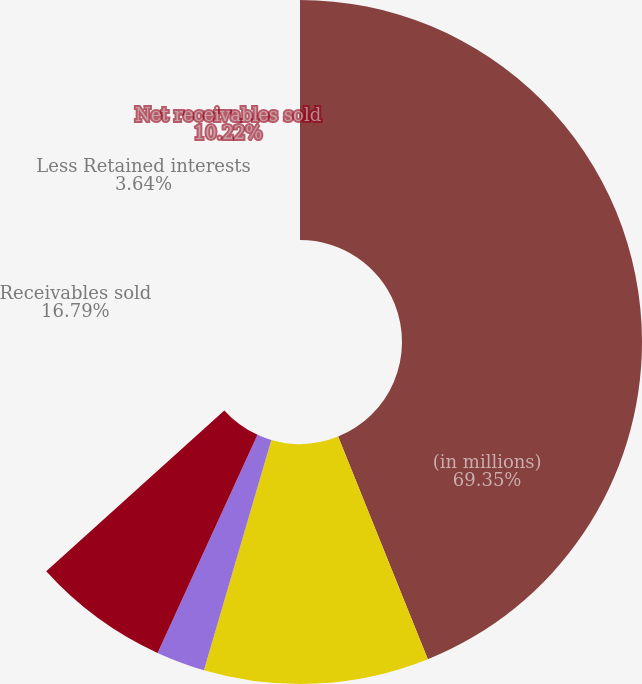<chart> <loc_0><loc_0><loc_500><loc_500><pie_chart><fcel>(in millions)<fcel>Receivables sold<fcel>Less Retained interests<fcel>Net receivables sold<nl><fcel>69.35%<fcel>16.79%<fcel>3.64%<fcel>10.22%<nl></chart> 